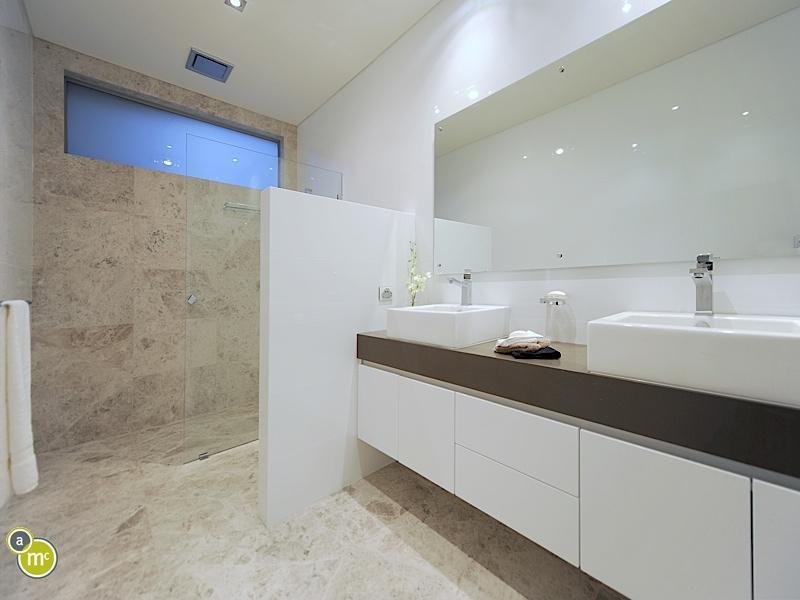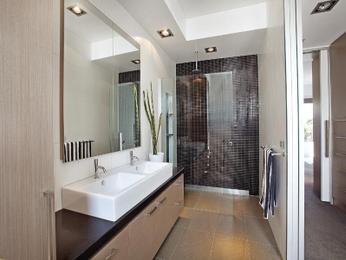The first image is the image on the left, the second image is the image on the right. For the images displayed, is the sentence "There are two separate but raised square sinks sitting on top of a wooden cabinet facing front left." factually correct? Answer yes or no. Yes. The first image is the image on the left, the second image is the image on the right. Assess this claim about the two images: "There are four faucets". Correct or not? Answer yes or no. Yes. 